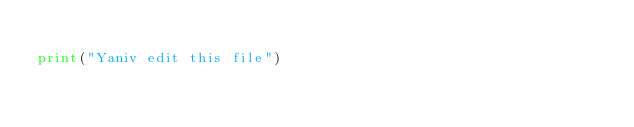Convert code to text. <code><loc_0><loc_0><loc_500><loc_500><_Python_>
print("Yaniv edit this file")
</code> 